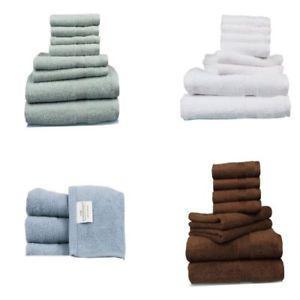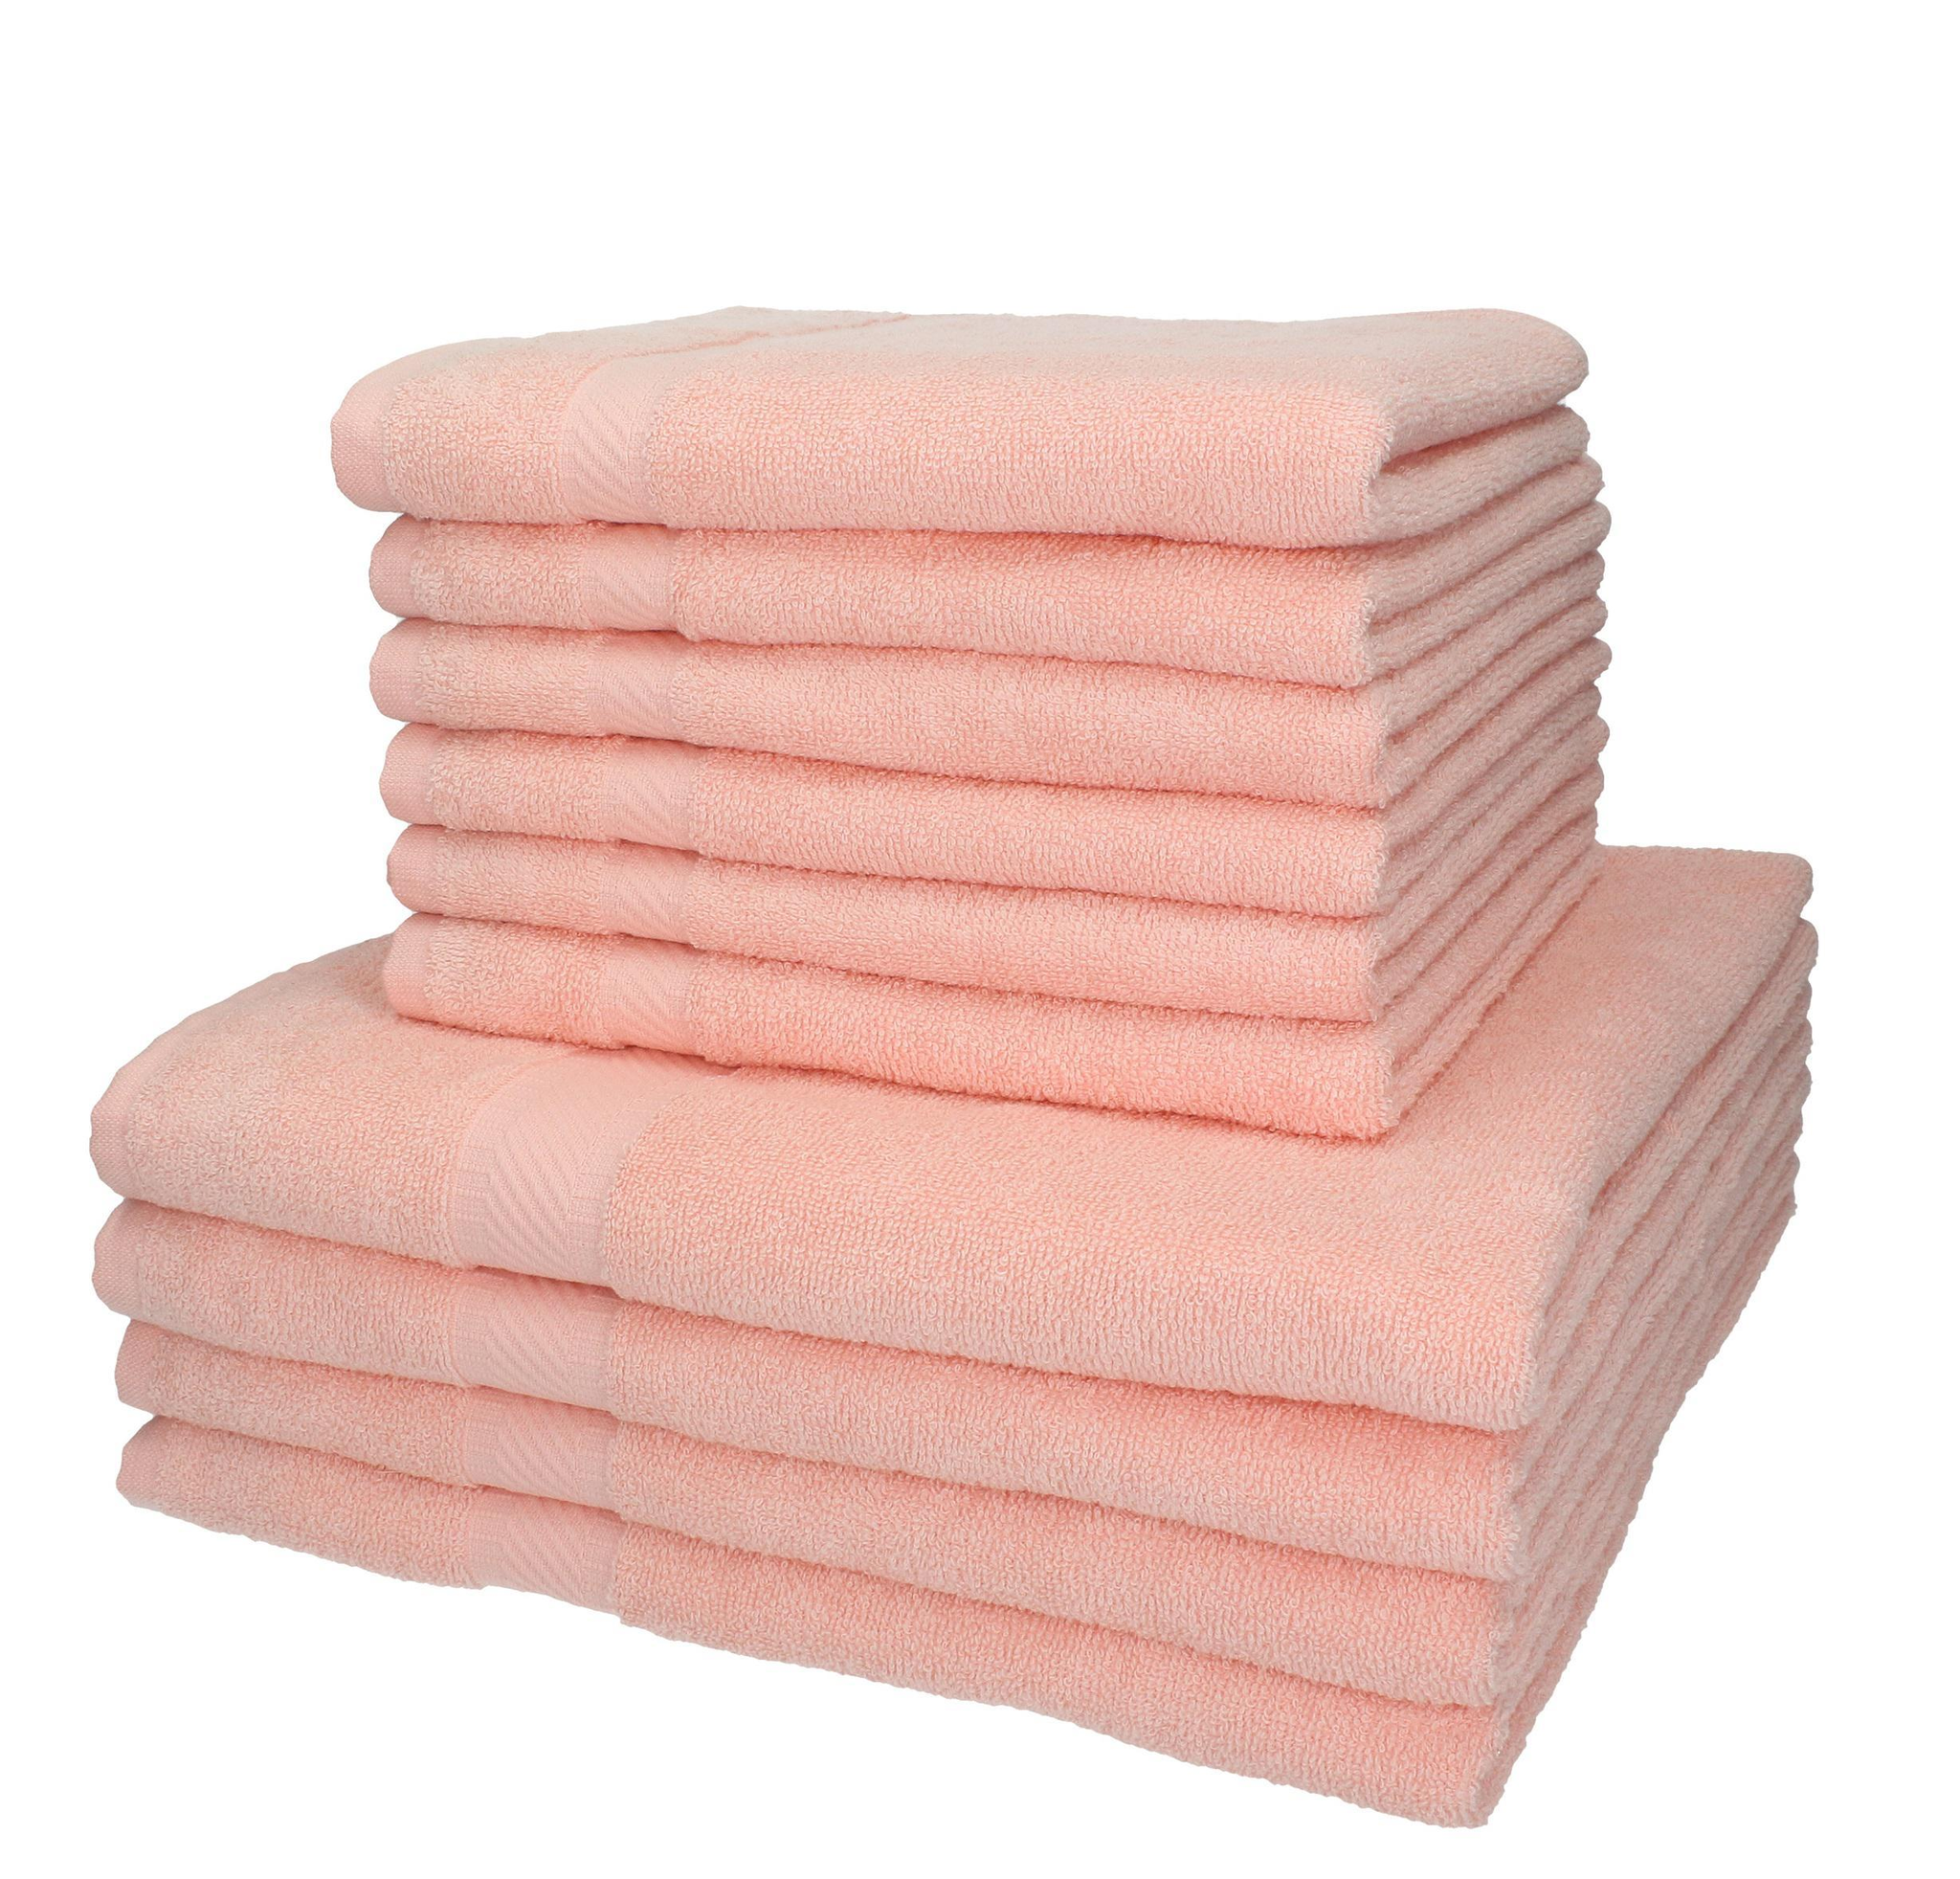The first image is the image on the left, the second image is the image on the right. For the images displayed, is the sentence "The stack of towels in one of the pictures is made up of only identical sized towels." factually correct? Answer yes or no. No. The first image is the image on the left, the second image is the image on the right. Evaluate the accuracy of this statement regarding the images: "There is a stack of all pink towels in one image.". Is it true? Answer yes or no. Yes. 